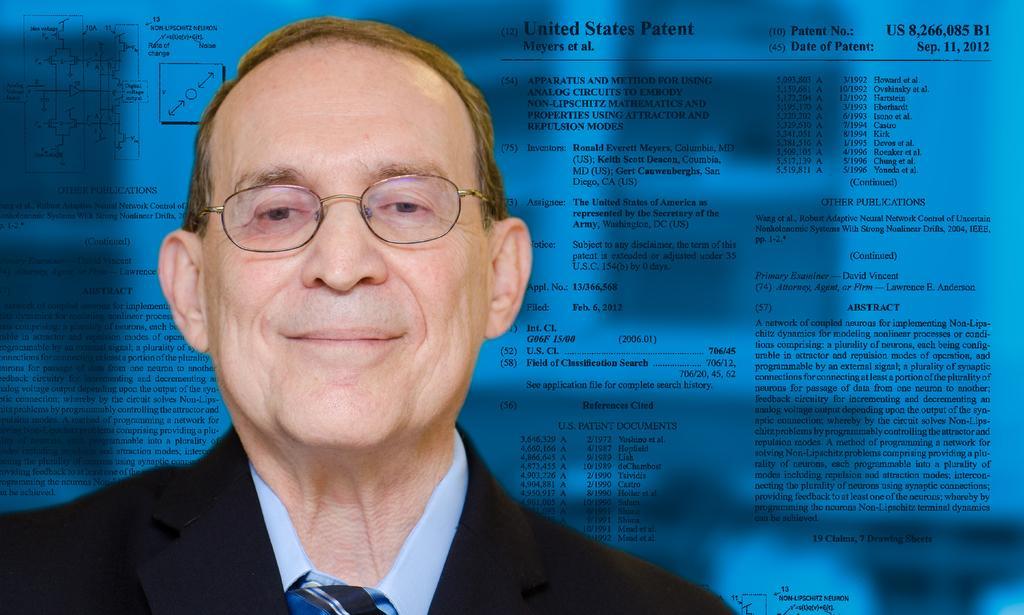Could you give a brief overview of what you see in this image? In this image I can see a person wearing white shirt, tie and black blazer is smiling. I can see he is wearing spectacles. In the background I can see blue surface and something printed on it. 